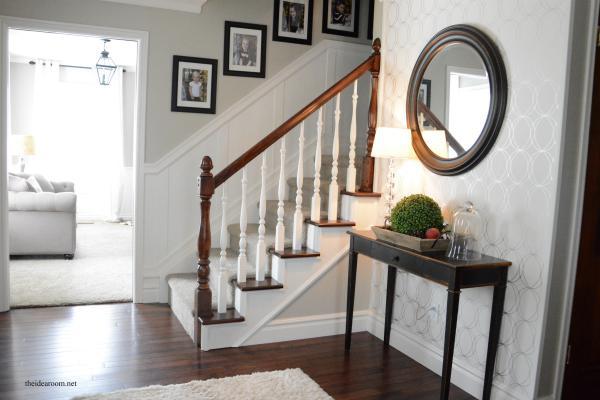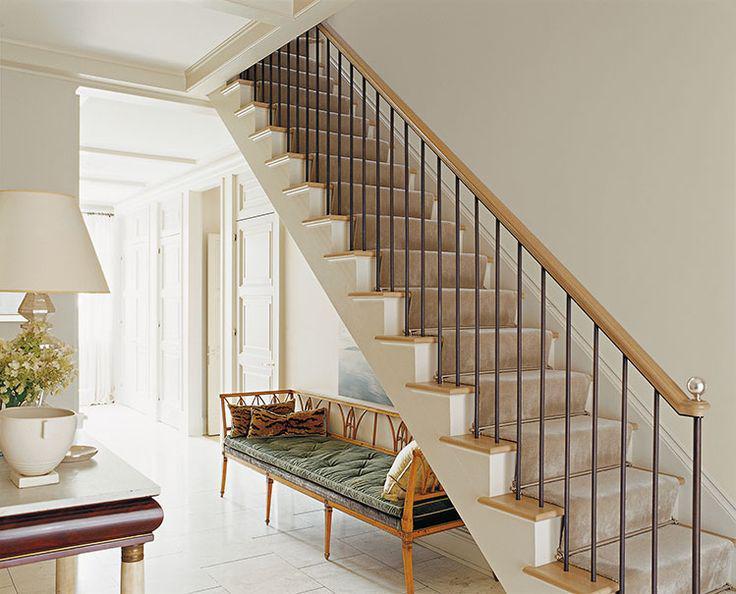The first image is the image on the left, the second image is the image on the right. Assess this claim about the two images: "The right image is taken from downstairs.". Correct or not? Answer yes or no. Yes. The first image is the image on the left, the second image is the image on the right. For the images displayed, is the sentence "The left image has visible stair steps, the right image does not." factually correct? Answer yes or no. No. 